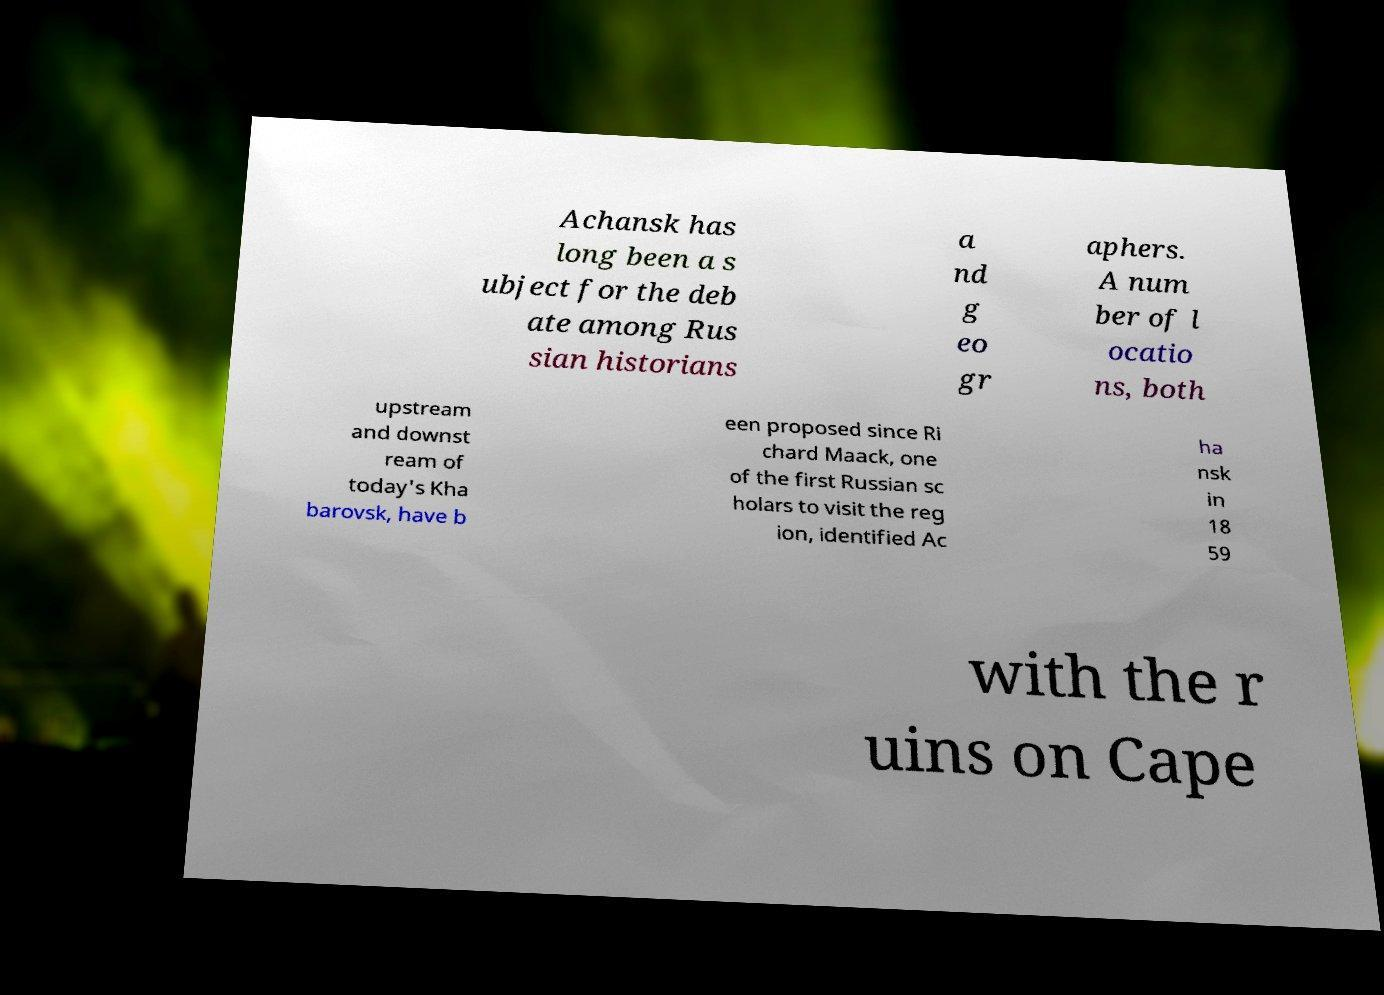For documentation purposes, I need the text within this image transcribed. Could you provide that? Achansk has long been a s ubject for the deb ate among Rus sian historians a nd g eo gr aphers. A num ber of l ocatio ns, both upstream and downst ream of today's Kha barovsk, have b een proposed since Ri chard Maack, one of the first Russian sc holars to visit the reg ion, identified Ac ha nsk in 18 59 with the r uins on Cape 